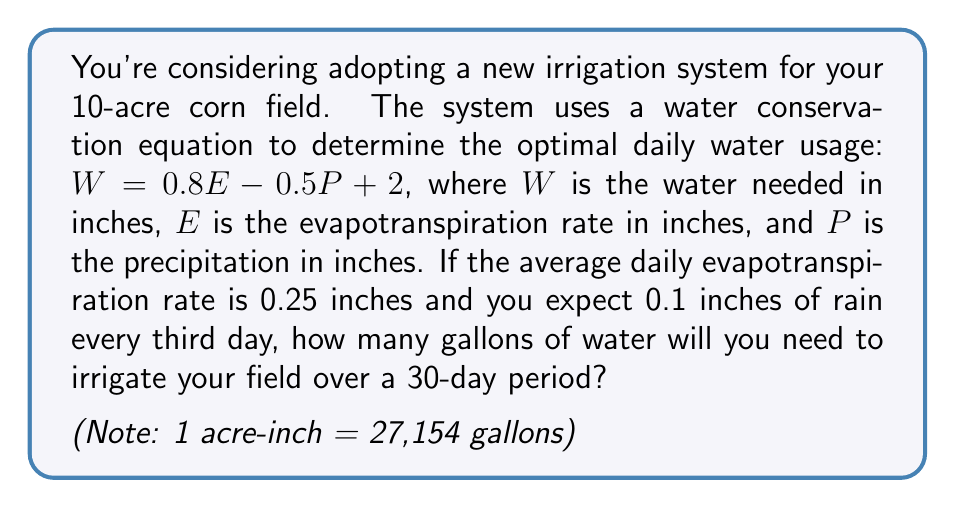Help me with this question. Let's approach this step-by-step:

1) First, we need to calculate the daily water usage for days with and without rain:

   For days without rain (P = 0):
   $W_{no rain} = 0.8(0.25) - 0.5(0) + 2 = 2.2$ inches

   For days with rain (P = 0.1):
   $W_{rain} = 0.8(0.25) - 0.5(0.1) + 2 = 2.15$ inches

2) In a 30-day period, we'll have 10 days with rain and 20 days without:
   
   Total water needed = $20(2.2) + 10(2.15) = 65.5$ acre-inches

3) For a 10-acre field, this becomes:
   
   $65.5 \times 10 = 655$ acre-inches

4) Convert acre-inches to gallons:
   
   $655 \times 27,154 = 17,785,870$ gallons

Therefore, over a 30-day period, you'll need approximately 17,785,870 gallons of water to irrigate your field.
Answer: 17,785,870 gallons 